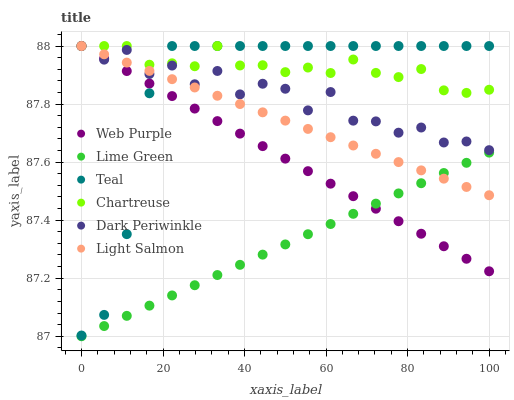Does Lime Green have the minimum area under the curve?
Answer yes or no. Yes. Does Chartreuse have the maximum area under the curve?
Answer yes or no. Yes. Does Web Purple have the minimum area under the curve?
Answer yes or no. No. Does Web Purple have the maximum area under the curve?
Answer yes or no. No. Is Lime Green the smoothest?
Answer yes or no. Yes. Is Dark Periwinkle the roughest?
Answer yes or no. Yes. Is Chartreuse the smoothest?
Answer yes or no. No. Is Chartreuse the roughest?
Answer yes or no. No. Does Lime Green have the lowest value?
Answer yes or no. Yes. Does Web Purple have the lowest value?
Answer yes or no. No. Does Dark Periwinkle have the highest value?
Answer yes or no. Yes. Does Lime Green have the highest value?
Answer yes or no. No. Is Lime Green less than Chartreuse?
Answer yes or no. Yes. Is Dark Periwinkle greater than Lime Green?
Answer yes or no. Yes. Does Chartreuse intersect Dark Periwinkle?
Answer yes or no. Yes. Is Chartreuse less than Dark Periwinkle?
Answer yes or no. No. Is Chartreuse greater than Dark Periwinkle?
Answer yes or no. No. Does Lime Green intersect Chartreuse?
Answer yes or no. No. 